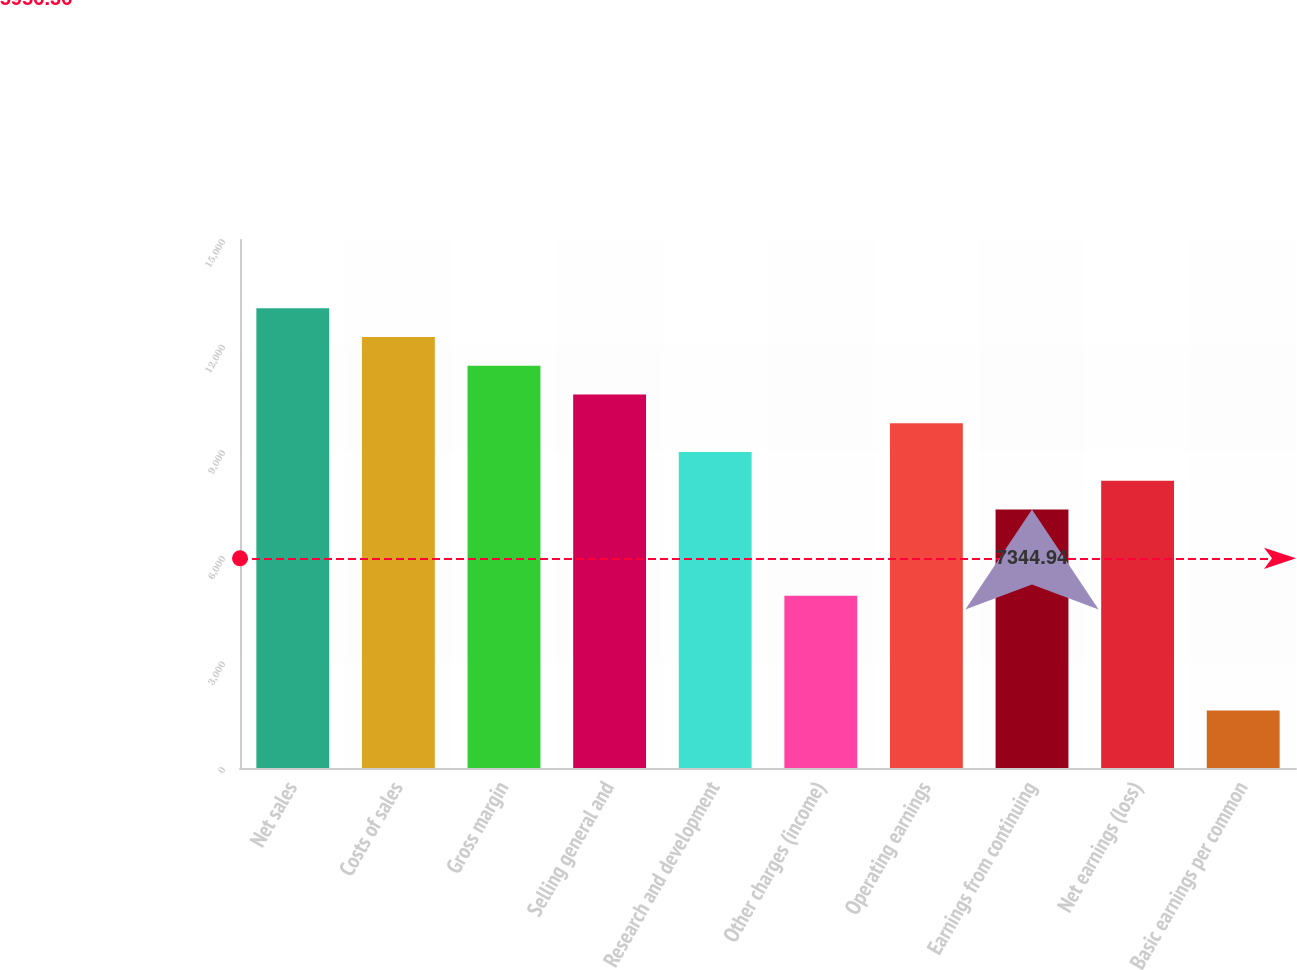<chart> <loc_0><loc_0><loc_500><loc_500><bar_chart><fcel>Net sales<fcel>Costs of sales<fcel>Gross margin<fcel>Selling general and<fcel>Research and development<fcel>Other charges (income)<fcel>Operating earnings<fcel>Earnings from continuing<fcel>Net earnings (loss)<fcel>Basic earnings per common<nl><fcel>13057.6<fcel>12241.5<fcel>11425.4<fcel>10609.3<fcel>8977.14<fcel>4896.64<fcel>9793.24<fcel>7344.94<fcel>8161.04<fcel>1632.24<nl></chart> 